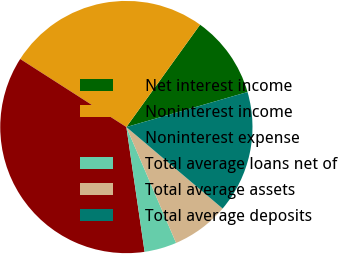Convert chart. <chart><loc_0><loc_0><loc_500><loc_500><pie_chart><fcel>Net interest income<fcel>Noninterest income<fcel>Noninterest expense<fcel>Total average loans net of<fcel>Total average assets<fcel>Total average deposits<nl><fcel>10.59%<fcel>25.86%<fcel>36.38%<fcel>4.14%<fcel>7.37%<fcel>15.66%<nl></chart> 